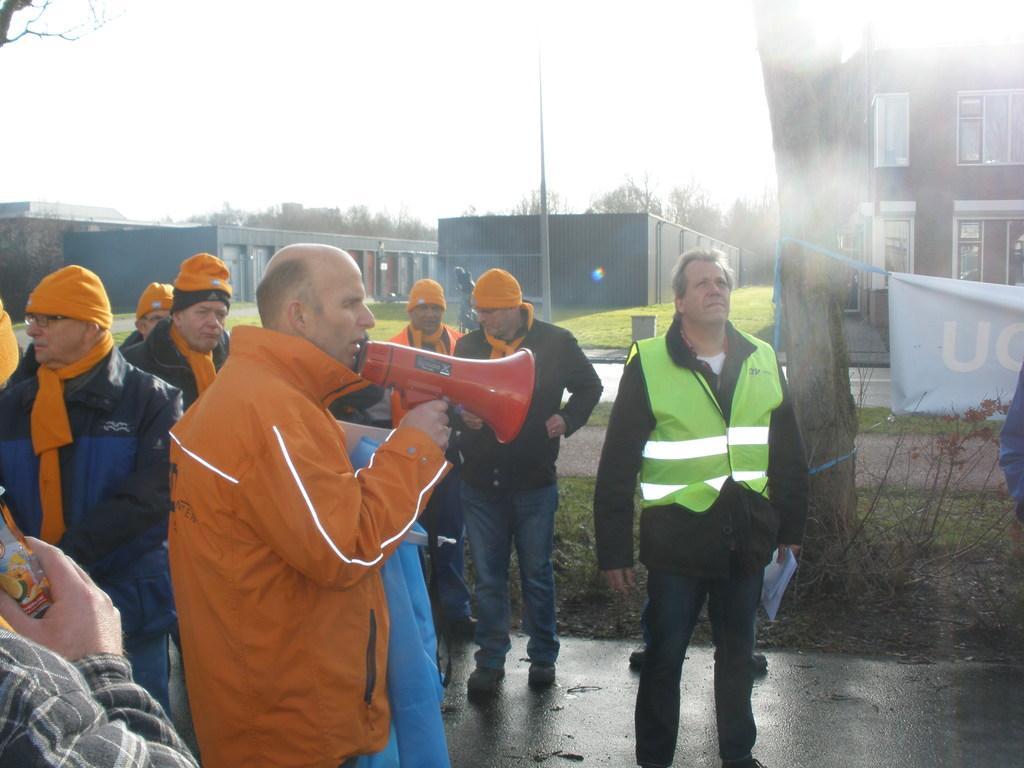Could you give a brief overview of what you see in this image? In the image there is a man standing and holding a loudspeaker in his hand. Behind him there are few men standing with orange caps on their heads. On the right side of the image there is a tree trunk with poster. On the ground there is grass. In the background there are buildings with walls and glass windows. And also there are trees and a pole in the background. 